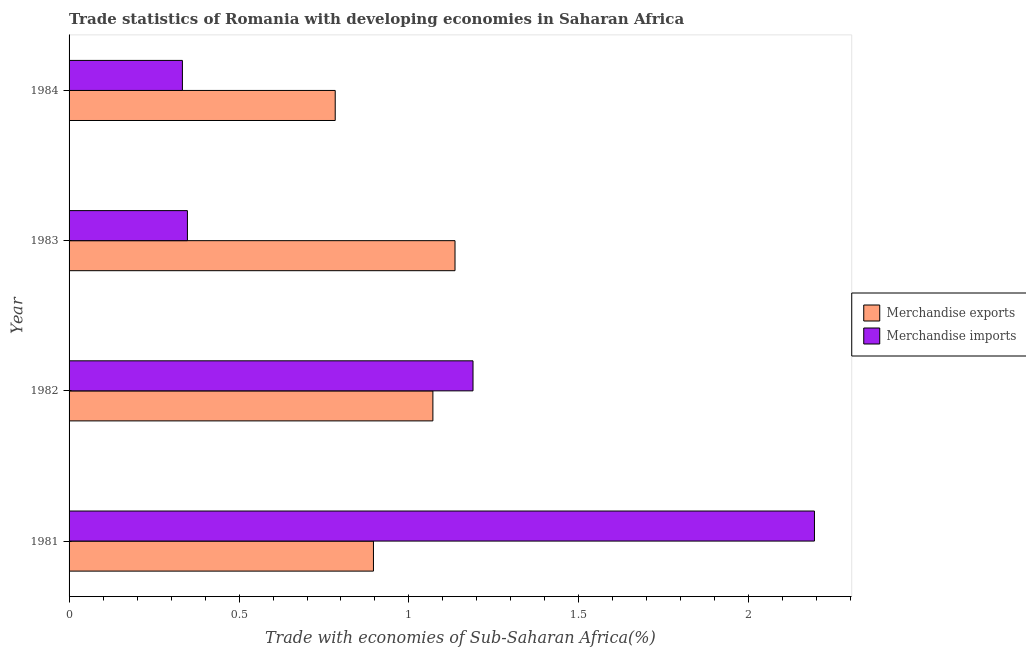How many groups of bars are there?
Give a very brief answer. 4. Are the number of bars per tick equal to the number of legend labels?
Your answer should be very brief. Yes. Are the number of bars on each tick of the Y-axis equal?
Make the answer very short. Yes. How many bars are there on the 4th tick from the bottom?
Offer a terse response. 2. In how many cases, is the number of bars for a given year not equal to the number of legend labels?
Make the answer very short. 0. What is the merchandise imports in 1981?
Offer a very short reply. 2.19. Across all years, what is the maximum merchandise exports?
Your answer should be compact. 1.14. Across all years, what is the minimum merchandise imports?
Your response must be concise. 0.33. In which year was the merchandise exports maximum?
Provide a succinct answer. 1983. In which year was the merchandise exports minimum?
Provide a succinct answer. 1984. What is the total merchandise imports in the graph?
Your answer should be very brief. 4.06. What is the difference between the merchandise imports in 1981 and that in 1984?
Keep it short and to the point. 1.86. What is the difference between the merchandise exports in 1984 and the merchandise imports in 1982?
Your response must be concise. -0.41. What is the average merchandise exports per year?
Provide a succinct answer. 0.97. In the year 1981, what is the difference between the merchandise imports and merchandise exports?
Offer a very short reply. 1.3. In how many years, is the merchandise exports greater than 0.30000000000000004 %?
Your answer should be very brief. 4. What is the ratio of the merchandise exports in 1983 to that in 1984?
Offer a very short reply. 1.45. Is the merchandise exports in 1981 less than that in 1983?
Make the answer very short. Yes. Is the difference between the merchandise exports in 1982 and 1984 greater than the difference between the merchandise imports in 1982 and 1984?
Your answer should be compact. No. What is the difference between the highest and the second highest merchandise exports?
Offer a terse response. 0.07. Is the sum of the merchandise exports in 1981 and 1983 greater than the maximum merchandise imports across all years?
Provide a short and direct response. No. What does the 2nd bar from the top in 1982 represents?
Provide a succinct answer. Merchandise exports. What does the 1st bar from the bottom in 1984 represents?
Ensure brevity in your answer.  Merchandise exports. How many bars are there?
Offer a terse response. 8. Are all the bars in the graph horizontal?
Ensure brevity in your answer.  Yes. How many years are there in the graph?
Make the answer very short. 4. Does the graph contain any zero values?
Offer a terse response. No. What is the title of the graph?
Give a very brief answer. Trade statistics of Romania with developing economies in Saharan Africa. Does "Resident workers" appear as one of the legend labels in the graph?
Offer a very short reply. No. What is the label or title of the X-axis?
Ensure brevity in your answer.  Trade with economies of Sub-Saharan Africa(%). What is the label or title of the Y-axis?
Offer a very short reply. Year. What is the Trade with economies of Sub-Saharan Africa(%) of Merchandise exports in 1981?
Keep it short and to the point. 0.9. What is the Trade with economies of Sub-Saharan Africa(%) in Merchandise imports in 1981?
Give a very brief answer. 2.19. What is the Trade with economies of Sub-Saharan Africa(%) of Merchandise exports in 1982?
Offer a very short reply. 1.07. What is the Trade with economies of Sub-Saharan Africa(%) in Merchandise imports in 1982?
Make the answer very short. 1.19. What is the Trade with economies of Sub-Saharan Africa(%) in Merchandise exports in 1983?
Ensure brevity in your answer.  1.14. What is the Trade with economies of Sub-Saharan Africa(%) in Merchandise imports in 1983?
Offer a terse response. 0.35. What is the Trade with economies of Sub-Saharan Africa(%) in Merchandise exports in 1984?
Give a very brief answer. 0.78. What is the Trade with economies of Sub-Saharan Africa(%) in Merchandise imports in 1984?
Make the answer very short. 0.33. Across all years, what is the maximum Trade with economies of Sub-Saharan Africa(%) of Merchandise exports?
Ensure brevity in your answer.  1.14. Across all years, what is the maximum Trade with economies of Sub-Saharan Africa(%) of Merchandise imports?
Provide a short and direct response. 2.19. Across all years, what is the minimum Trade with economies of Sub-Saharan Africa(%) of Merchandise exports?
Your response must be concise. 0.78. Across all years, what is the minimum Trade with economies of Sub-Saharan Africa(%) in Merchandise imports?
Provide a succinct answer. 0.33. What is the total Trade with economies of Sub-Saharan Africa(%) of Merchandise exports in the graph?
Your answer should be very brief. 3.88. What is the total Trade with economies of Sub-Saharan Africa(%) of Merchandise imports in the graph?
Give a very brief answer. 4.06. What is the difference between the Trade with economies of Sub-Saharan Africa(%) of Merchandise exports in 1981 and that in 1982?
Ensure brevity in your answer.  -0.17. What is the difference between the Trade with economies of Sub-Saharan Africa(%) of Merchandise imports in 1981 and that in 1982?
Provide a succinct answer. 1. What is the difference between the Trade with economies of Sub-Saharan Africa(%) in Merchandise exports in 1981 and that in 1983?
Provide a short and direct response. -0.24. What is the difference between the Trade with economies of Sub-Saharan Africa(%) of Merchandise imports in 1981 and that in 1983?
Keep it short and to the point. 1.84. What is the difference between the Trade with economies of Sub-Saharan Africa(%) of Merchandise exports in 1981 and that in 1984?
Offer a terse response. 0.11. What is the difference between the Trade with economies of Sub-Saharan Africa(%) in Merchandise imports in 1981 and that in 1984?
Make the answer very short. 1.86. What is the difference between the Trade with economies of Sub-Saharan Africa(%) of Merchandise exports in 1982 and that in 1983?
Keep it short and to the point. -0.07. What is the difference between the Trade with economies of Sub-Saharan Africa(%) in Merchandise imports in 1982 and that in 1983?
Give a very brief answer. 0.84. What is the difference between the Trade with economies of Sub-Saharan Africa(%) in Merchandise exports in 1982 and that in 1984?
Offer a very short reply. 0.29. What is the difference between the Trade with economies of Sub-Saharan Africa(%) of Merchandise imports in 1982 and that in 1984?
Offer a very short reply. 0.85. What is the difference between the Trade with economies of Sub-Saharan Africa(%) of Merchandise exports in 1983 and that in 1984?
Your answer should be very brief. 0.35. What is the difference between the Trade with economies of Sub-Saharan Africa(%) of Merchandise imports in 1983 and that in 1984?
Your answer should be very brief. 0.01. What is the difference between the Trade with economies of Sub-Saharan Africa(%) of Merchandise exports in 1981 and the Trade with economies of Sub-Saharan Africa(%) of Merchandise imports in 1982?
Ensure brevity in your answer.  -0.29. What is the difference between the Trade with economies of Sub-Saharan Africa(%) in Merchandise exports in 1981 and the Trade with economies of Sub-Saharan Africa(%) in Merchandise imports in 1983?
Your answer should be very brief. 0.55. What is the difference between the Trade with economies of Sub-Saharan Africa(%) of Merchandise exports in 1981 and the Trade with economies of Sub-Saharan Africa(%) of Merchandise imports in 1984?
Your answer should be very brief. 0.56. What is the difference between the Trade with economies of Sub-Saharan Africa(%) of Merchandise exports in 1982 and the Trade with economies of Sub-Saharan Africa(%) of Merchandise imports in 1983?
Offer a very short reply. 0.72. What is the difference between the Trade with economies of Sub-Saharan Africa(%) in Merchandise exports in 1982 and the Trade with economies of Sub-Saharan Africa(%) in Merchandise imports in 1984?
Provide a short and direct response. 0.74. What is the difference between the Trade with economies of Sub-Saharan Africa(%) of Merchandise exports in 1983 and the Trade with economies of Sub-Saharan Africa(%) of Merchandise imports in 1984?
Provide a short and direct response. 0.8. What is the average Trade with economies of Sub-Saharan Africa(%) in Merchandise exports per year?
Provide a short and direct response. 0.97. What is the average Trade with economies of Sub-Saharan Africa(%) of Merchandise imports per year?
Offer a very short reply. 1.02. In the year 1981, what is the difference between the Trade with economies of Sub-Saharan Africa(%) of Merchandise exports and Trade with economies of Sub-Saharan Africa(%) of Merchandise imports?
Provide a succinct answer. -1.3. In the year 1982, what is the difference between the Trade with economies of Sub-Saharan Africa(%) in Merchandise exports and Trade with economies of Sub-Saharan Africa(%) in Merchandise imports?
Provide a short and direct response. -0.12. In the year 1983, what is the difference between the Trade with economies of Sub-Saharan Africa(%) of Merchandise exports and Trade with economies of Sub-Saharan Africa(%) of Merchandise imports?
Make the answer very short. 0.79. In the year 1984, what is the difference between the Trade with economies of Sub-Saharan Africa(%) of Merchandise exports and Trade with economies of Sub-Saharan Africa(%) of Merchandise imports?
Provide a succinct answer. 0.45. What is the ratio of the Trade with economies of Sub-Saharan Africa(%) of Merchandise exports in 1981 to that in 1982?
Your answer should be very brief. 0.84. What is the ratio of the Trade with economies of Sub-Saharan Africa(%) of Merchandise imports in 1981 to that in 1982?
Ensure brevity in your answer.  1.85. What is the ratio of the Trade with economies of Sub-Saharan Africa(%) in Merchandise exports in 1981 to that in 1983?
Give a very brief answer. 0.79. What is the ratio of the Trade with economies of Sub-Saharan Africa(%) in Merchandise imports in 1981 to that in 1983?
Keep it short and to the point. 6.3. What is the ratio of the Trade with economies of Sub-Saharan Africa(%) in Merchandise exports in 1981 to that in 1984?
Keep it short and to the point. 1.14. What is the ratio of the Trade with economies of Sub-Saharan Africa(%) in Merchandise imports in 1981 to that in 1984?
Make the answer very short. 6.58. What is the ratio of the Trade with economies of Sub-Saharan Africa(%) in Merchandise exports in 1982 to that in 1983?
Offer a terse response. 0.94. What is the ratio of the Trade with economies of Sub-Saharan Africa(%) of Merchandise imports in 1982 to that in 1983?
Offer a terse response. 3.41. What is the ratio of the Trade with economies of Sub-Saharan Africa(%) in Merchandise exports in 1982 to that in 1984?
Provide a succinct answer. 1.37. What is the ratio of the Trade with economies of Sub-Saharan Africa(%) of Merchandise imports in 1982 to that in 1984?
Provide a succinct answer. 3.56. What is the ratio of the Trade with economies of Sub-Saharan Africa(%) in Merchandise exports in 1983 to that in 1984?
Offer a very short reply. 1.45. What is the ratio of the Trade with economies of Sub-Saharan Africa(%) in Merchandise imports in 1983 to that in 1984?
Provide a succinct answer. 1.04. What is the difference between the highest and the second highest Trade with economies of Sub-Saharan Africa(%) in Merchandise exports?
Provide a succinct answer. 0.07. What is the difference between the highest and the lowest Trade with economies of Sub-Saharan Africa(%) in Merchandise exports?
Give a very brief answer. 0.35. What is the difference between the highest and the lowest Trade with economies of Sub-Saharan Africa(%) of Merchandise imports?
Ensure brevity in your answer.  1.86. 